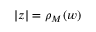<formula> <loc_0><loc_0><loc_500><loc_500>| z | = \rho _ { M } ( w )</formula> 